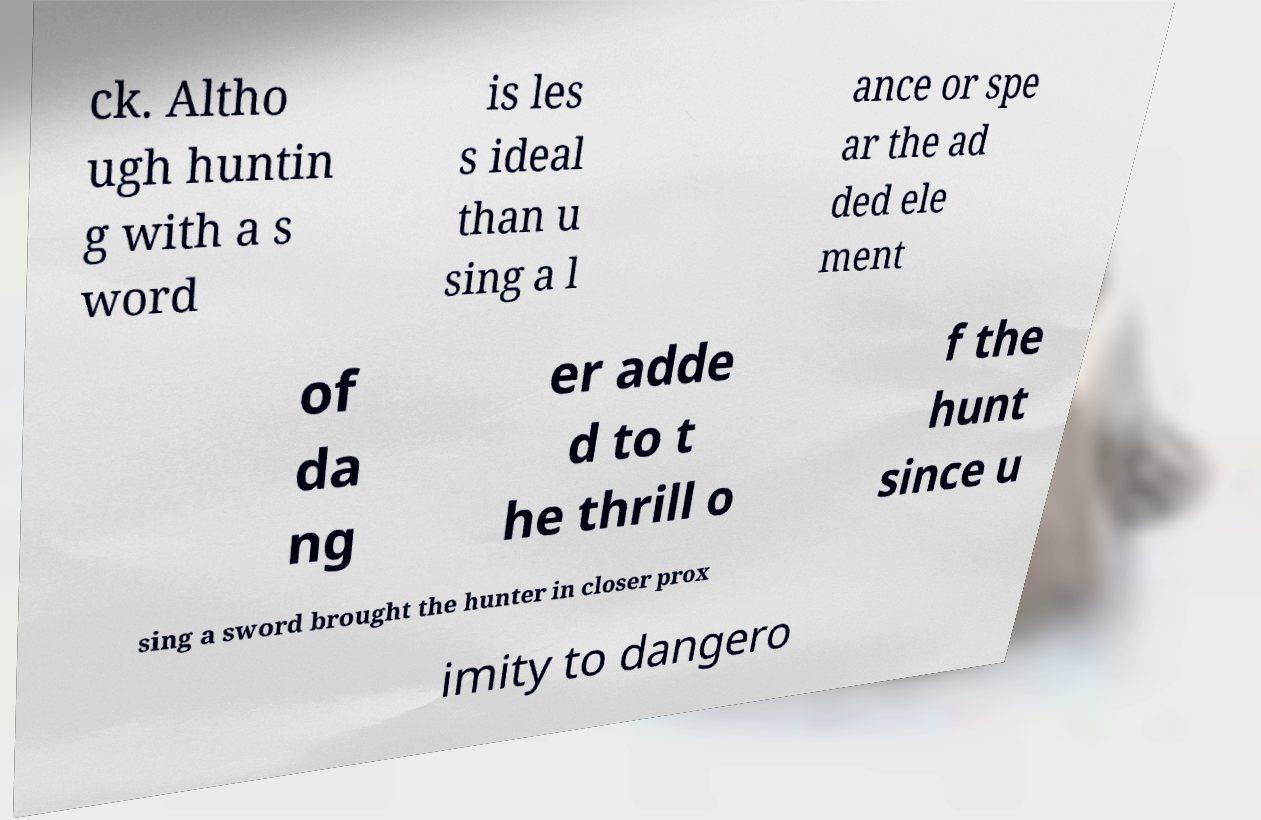Could you assist in decoding the text presented in this image and type it out clearly? ck. Altho ugh huntin g with a s word is les s ideal than u sing a l ance or spe ar the ad ded ele ment of da ng er adde d to t he thrill o f the hunt since u sing a sword brought the hunter in closer prox imity to dangero 